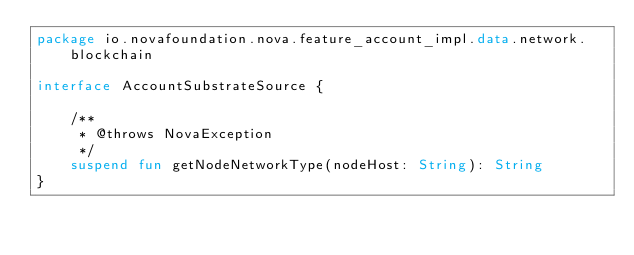Convert code to text. <code><loc_0><loc_0><loc_500><loc_500><_Kotlin_>package io.novafoundation.nova.feature_account_impl.data.network.blockchain

interface AccountSubstrateSource {

    /**
     * @throws NovaException
     */
    suspend fun getNodeNetworkType(nodeHost: String): String
}
</code> 